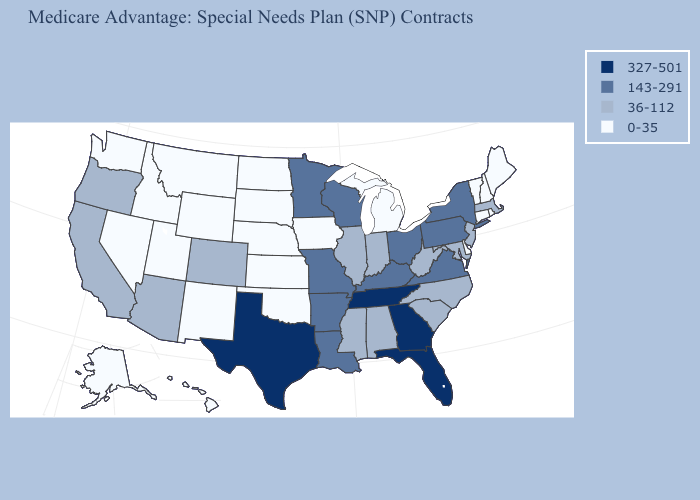What is the value of Delaware?
Give a very brief answer. 0-35. Which states hav the highest value in the Northeast?
Give a very brief answer. New York, Pennsylvania. What is the value of Wyoming?
Write a very short answer. 0-35. What is the value of Ohio?
Keep it brief. 143-291. Name the states that have a value in the range 143-291?
Answer briefly. Arkansas, Kentucky, Louisiana, Minnesota, Missouri, New York, Ohio, Pennsylvania, Virginia, Wisconsin. What is the lowest value in the Northeast?
Concise answer only. 0-35. Name the states that have a value in the range 36-112?
Give a very brief answer. Alabama, Arizona, California, Colorado, Illinois, Indiana, Massachusetts, Maryland, Mississippi, North Carolina, New Jersey, Oregon, South Carolina, West Virginia. Name the states that have a value in the range 36-112?
Keep it brief. Alabama, Arizona, California, Colorado, Illinois, Indiana, Massachusetts, Maryland, Mississippi, North Carolina, New Jersey, Oregon, South Carolina, West Virginia. Among the states that border Louisiana , which have the highest value?
Keep it brief. Texas. Name the states that have a value in the range 36-112?
Keep it brief. Alabama, Arizona, California, Colorado, Illinois, Indiana, Massachusetts, Maryland, Mississippi, North Carolina, New Jersey, Oregon, South Carolina, West Virginia. Name the states that have a value in the range 36-112?
Be succinct. Alabama, Arizona, California, Colorado, Illinois, Indiana, Massachusetts, Maryland, Mississippi, North Carolina, New Jersey, Oregon, South Carolina, West Virginia. What is the value of Kentucky?
Quick response, please. 143-291. Does the map have missing data?
Keep it brief. No. What is the highest value in the USA?
Give a very brief answer. 327-501. Among the states that border Connecticut , does Rhode Island have the lowest value?
Write a very short answer. Yes. 